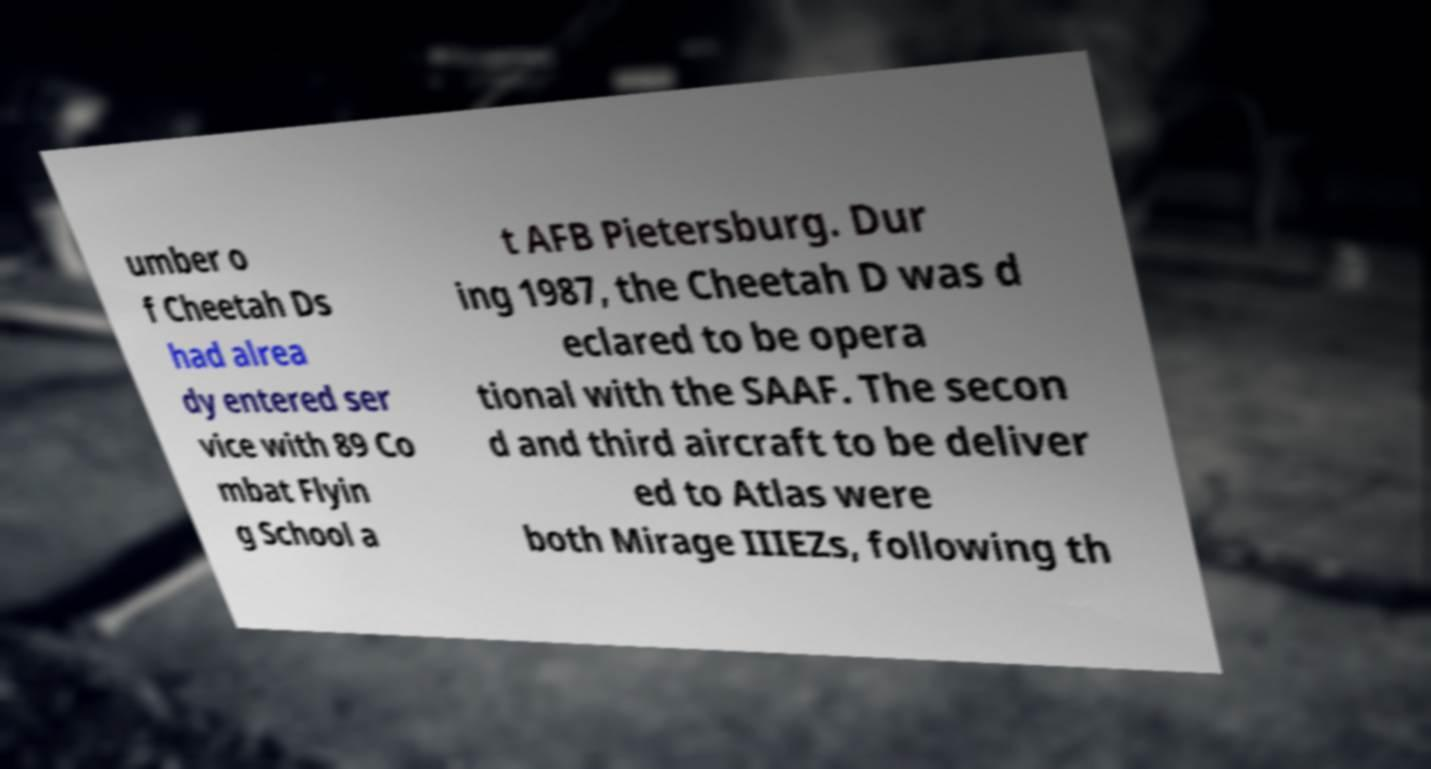Could you assist in decoding the text presented in this image and type it out clearly? umber o f Cheetah Ds had alrea dy entered ser vice with 89 Co mbat Flyin g School a t AFB Pietersburg. Dur ing 1987, the Cheetah D was d eclared to be opera tional with the SAAF. The secon d and third aircraft to be deliver ed to Atlas were both Mirage IIIEZs, following th 